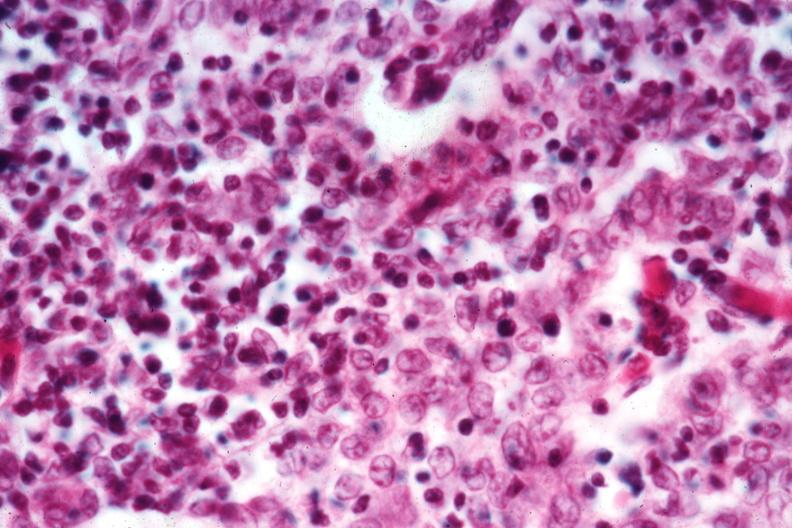what is present?
Answer the question using a single word or phrase. Hematologic 